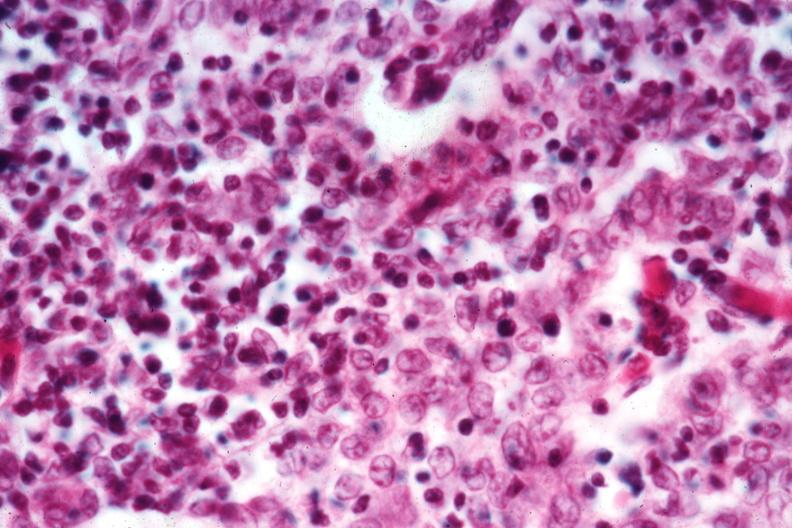what is present?
Answer the question using a single word or phrase. Hematologic 